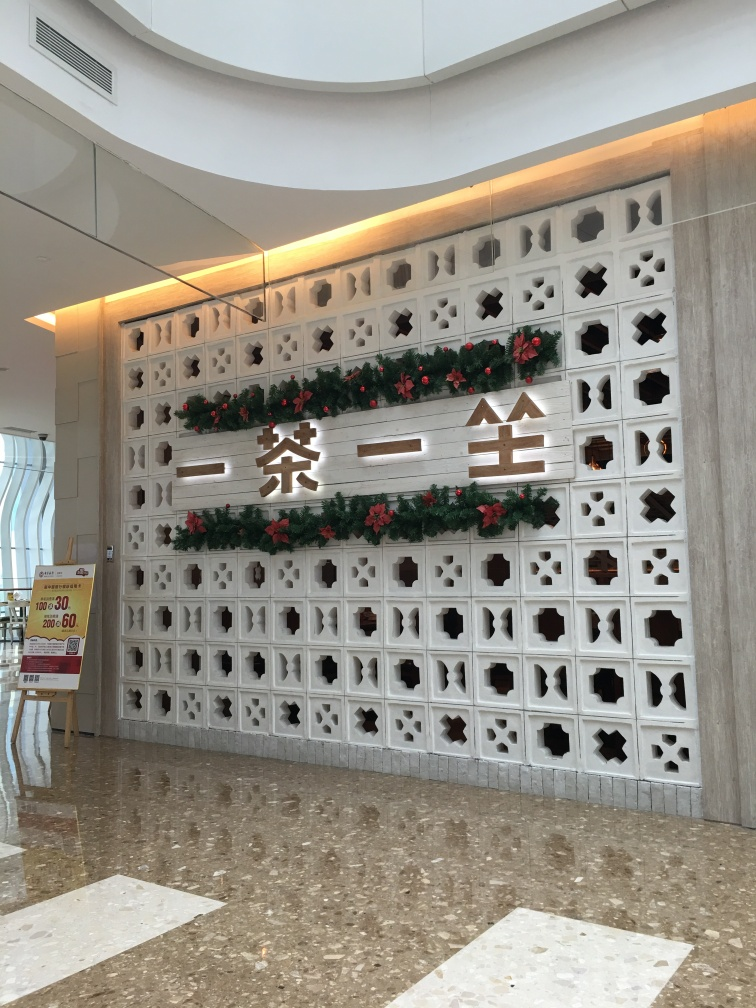Delve into the quality of the photograph and give a verdict based on your scrutiny.
 This image has high illumination, and the textures and fonts on the wall are clear. Therefore, the quality of this image is very good. 